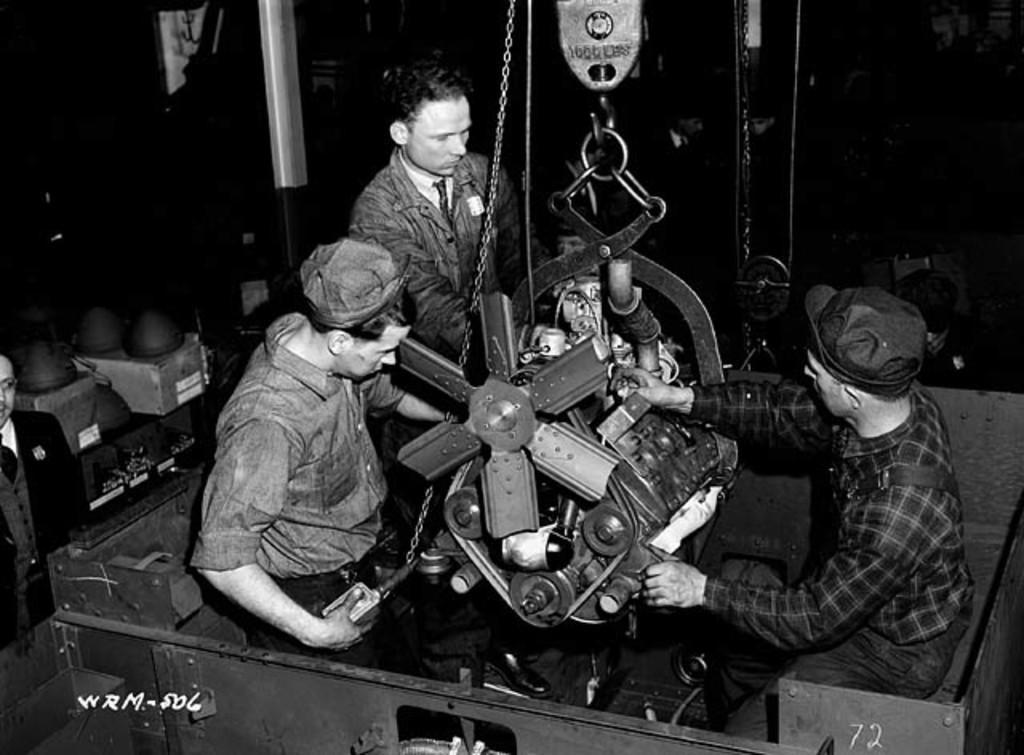Could you give a brief overview of what you see in this image? This is a black and white picture. In this picture we can see a machine and a man is standing near to it. We can see the other two men wearing caps and sitting. On the left side of the picture we can see a person and few objects. In the bottom left corner of the picture we can see watermark. 